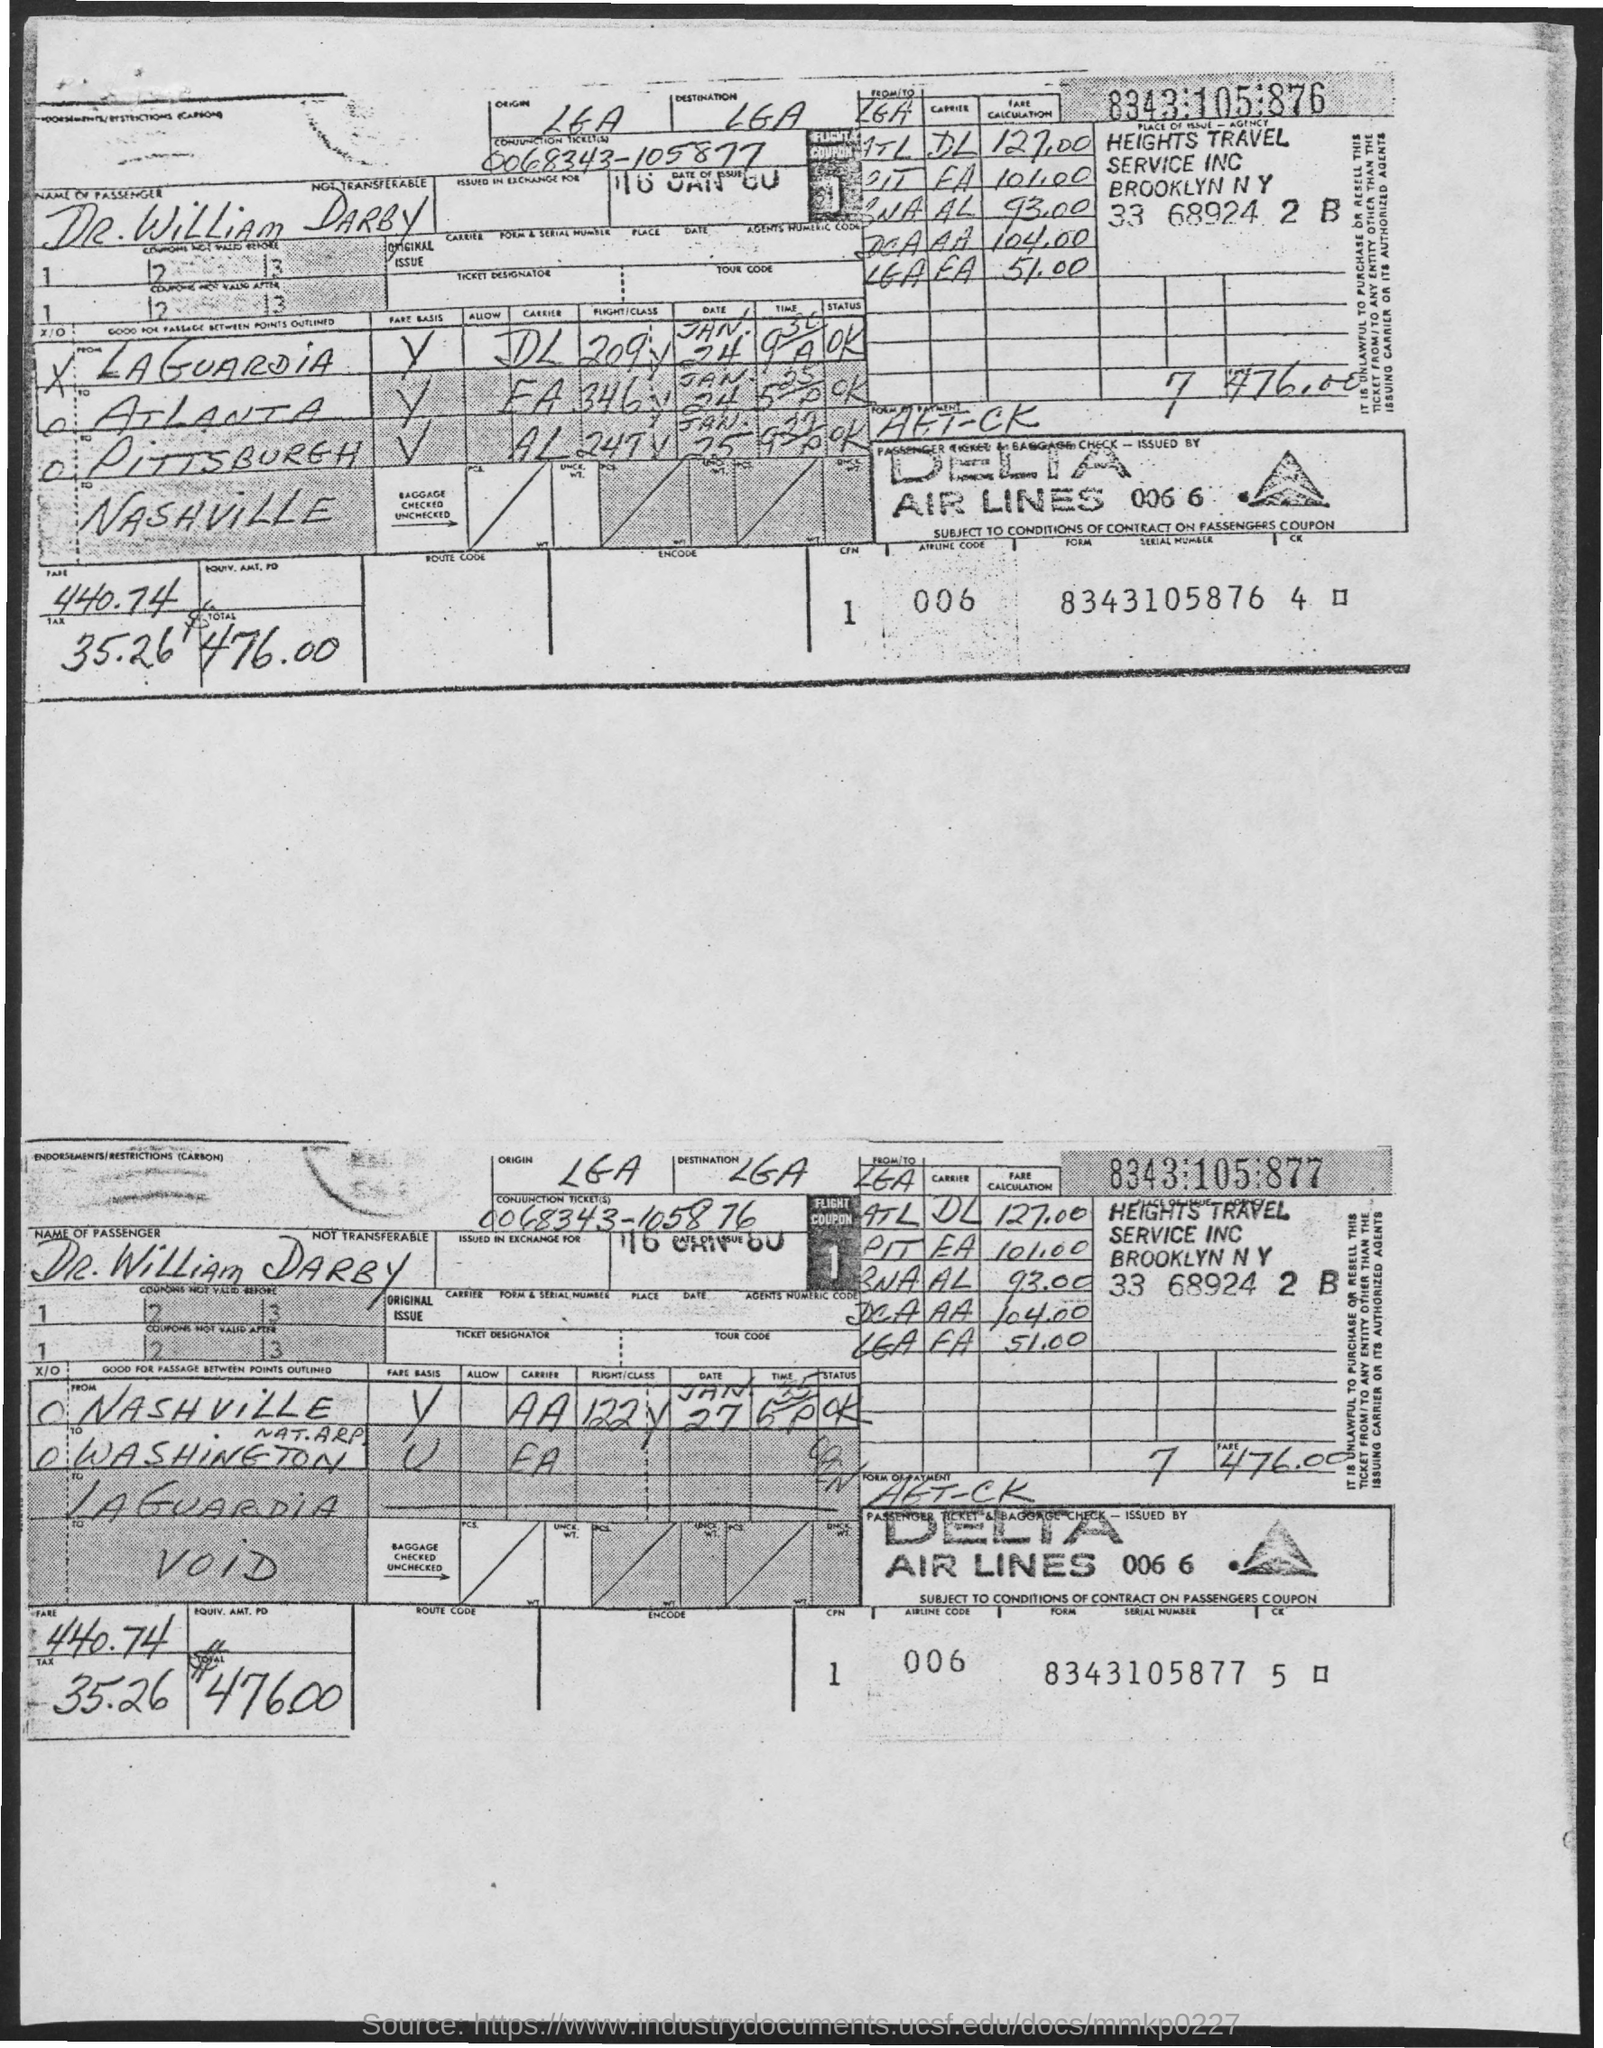Identify some key points in this picture. The total amount is $476.00. The airline code is 006. Can you please provide the serial number for the form? The passenger's name is Dr. William Darby. 